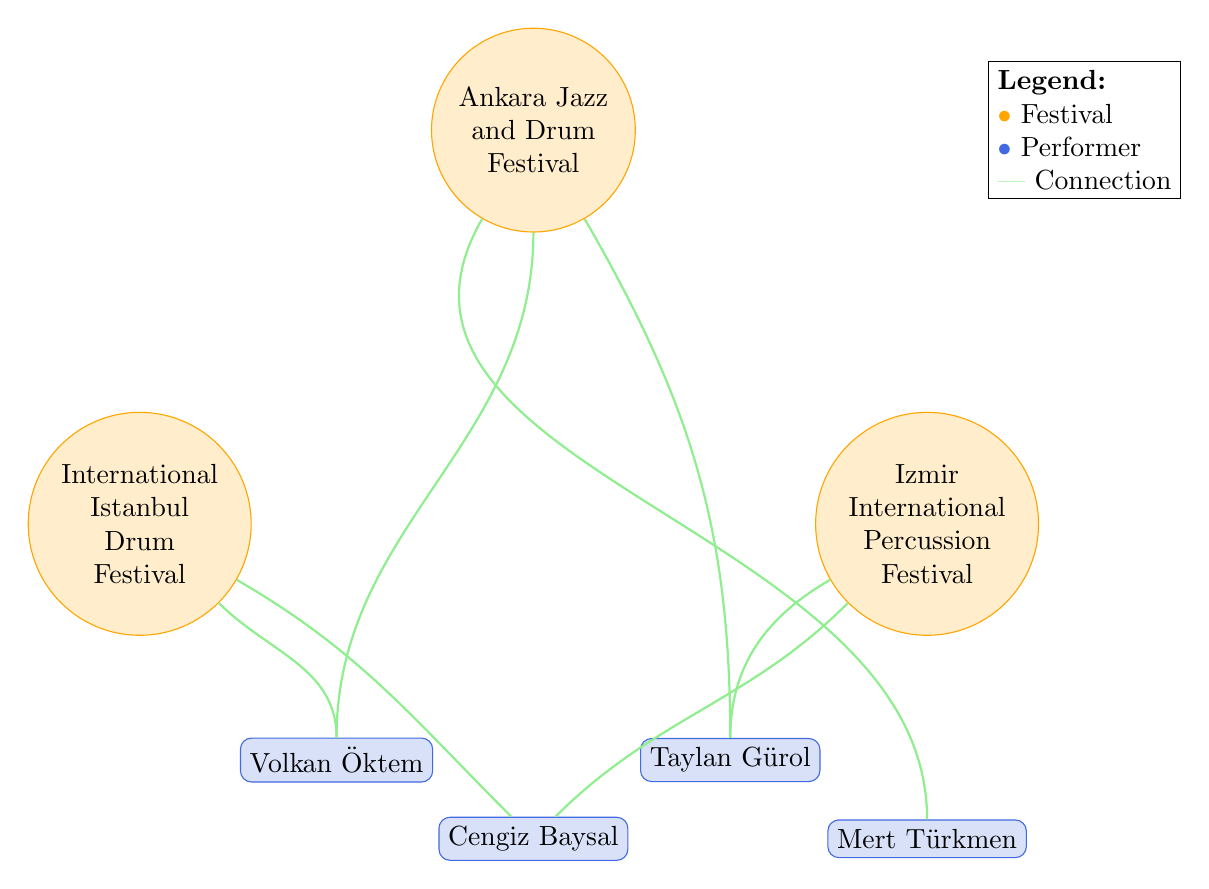What's the total number of drum festivals in the diagram? There are three distinct nodes labeled as festivals in the diagram: International Istanbul Drum Festival, Ankara Jazz and Drum Festival, and Izmir International Percussion Festival. Therefore, the total number is three.
Answer: 3 Which performer is associated with the most festivals? By examining the connections, Volkan Öktem links to two festivals: International Istanbul Drum Festival and Ankara Jazz and Drum Festival. The other performers link to either one or two less. Thus, Volkan Öktem is associated with the most festivals.
Answer: Volkan Öktem How many performers are part of the International Istanbul Drum Festival? The International Istanbul Drum Festival has two connections: one to Volkan Öktem and another to Cengiz Baysal, making it a total of two performers participating.
Answer: 2 Is Taylan Gürol associated with the Izmir International Percussion Festival? Taylan Gürol is connected to the Izmir International Percussion Festival, as indicated by the connection in the diagram. Thus, the answer is yes.
Answer: Yes Which festivals feature Cengiz Baysal? Cengiz Baysal appears in two relationships, connecting to both the International Istanbul Drum Festival and the Izmir International Percussion Festival as shown in the diagram.
Answer: International Istanbul Drum Festival, Izmir International Percussion Festival What is the relationship pattern visible for the Ankara Jazz and Drum Festival? The Ankara Jazz and Drum Festival has three connections to performers: Taylan Gürol, Mert Türkmen, and Volkan Öktem. This shows that it features multiple star performers.
Answer: Multiple performers How many connections does Mert Türkmen have? Mert Türkmen is linked to the Ankara Jazz and Drum Festival, showing that he has only one connection within the diagram.
Answer: 1 Which two performers are connected to the Izmir International Percussion Festival? The diagram indicates that Cengiz Baysal and Taylan Gürol are both linked to the Izmir International Percussion Festival, making them the only two performers connected to this festival.
Answer: Cengiz Baysal, Taylan Gürol 